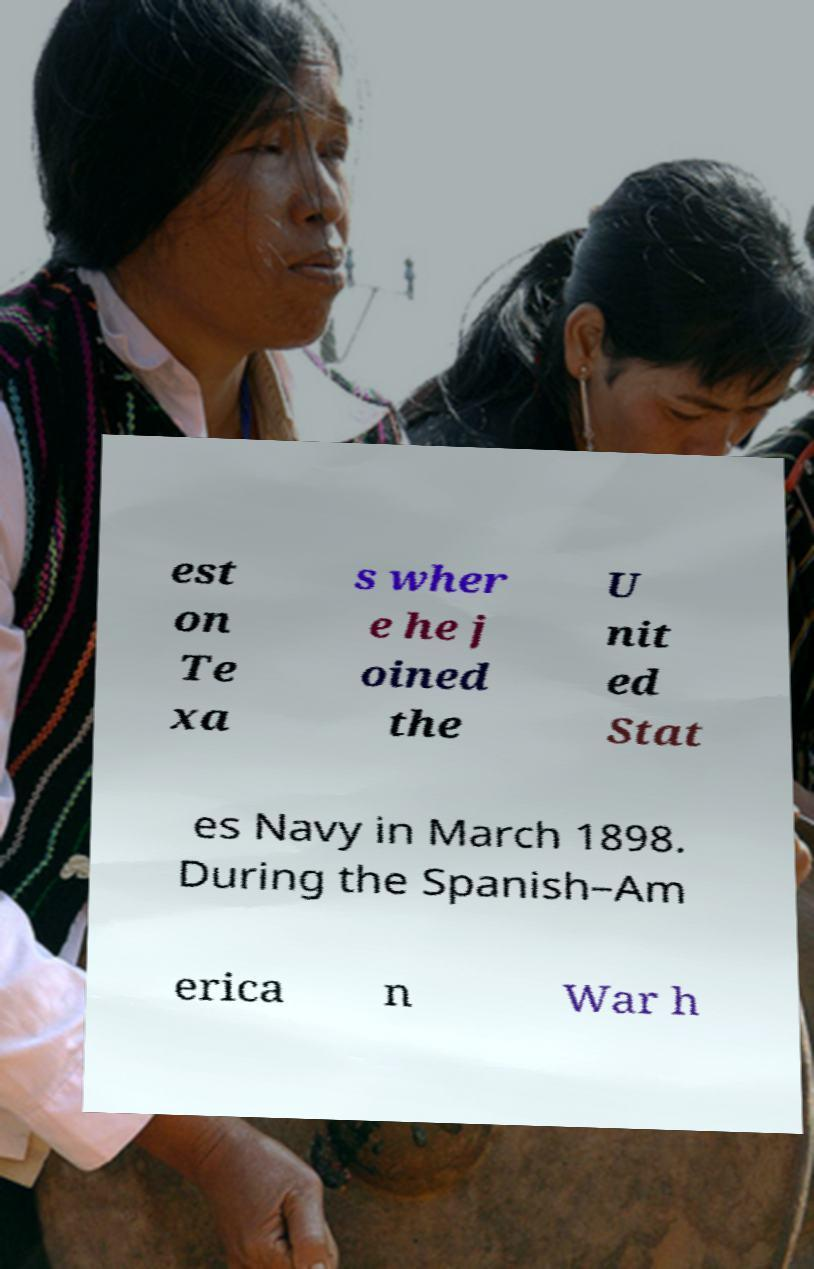For documentation purposes, I need the text within this image transcribed. Could you provide that? est on Te xa s wher e he j oined the U nit ed Stat es Navy in March 1898. During the Spanish–Am erica n War h 